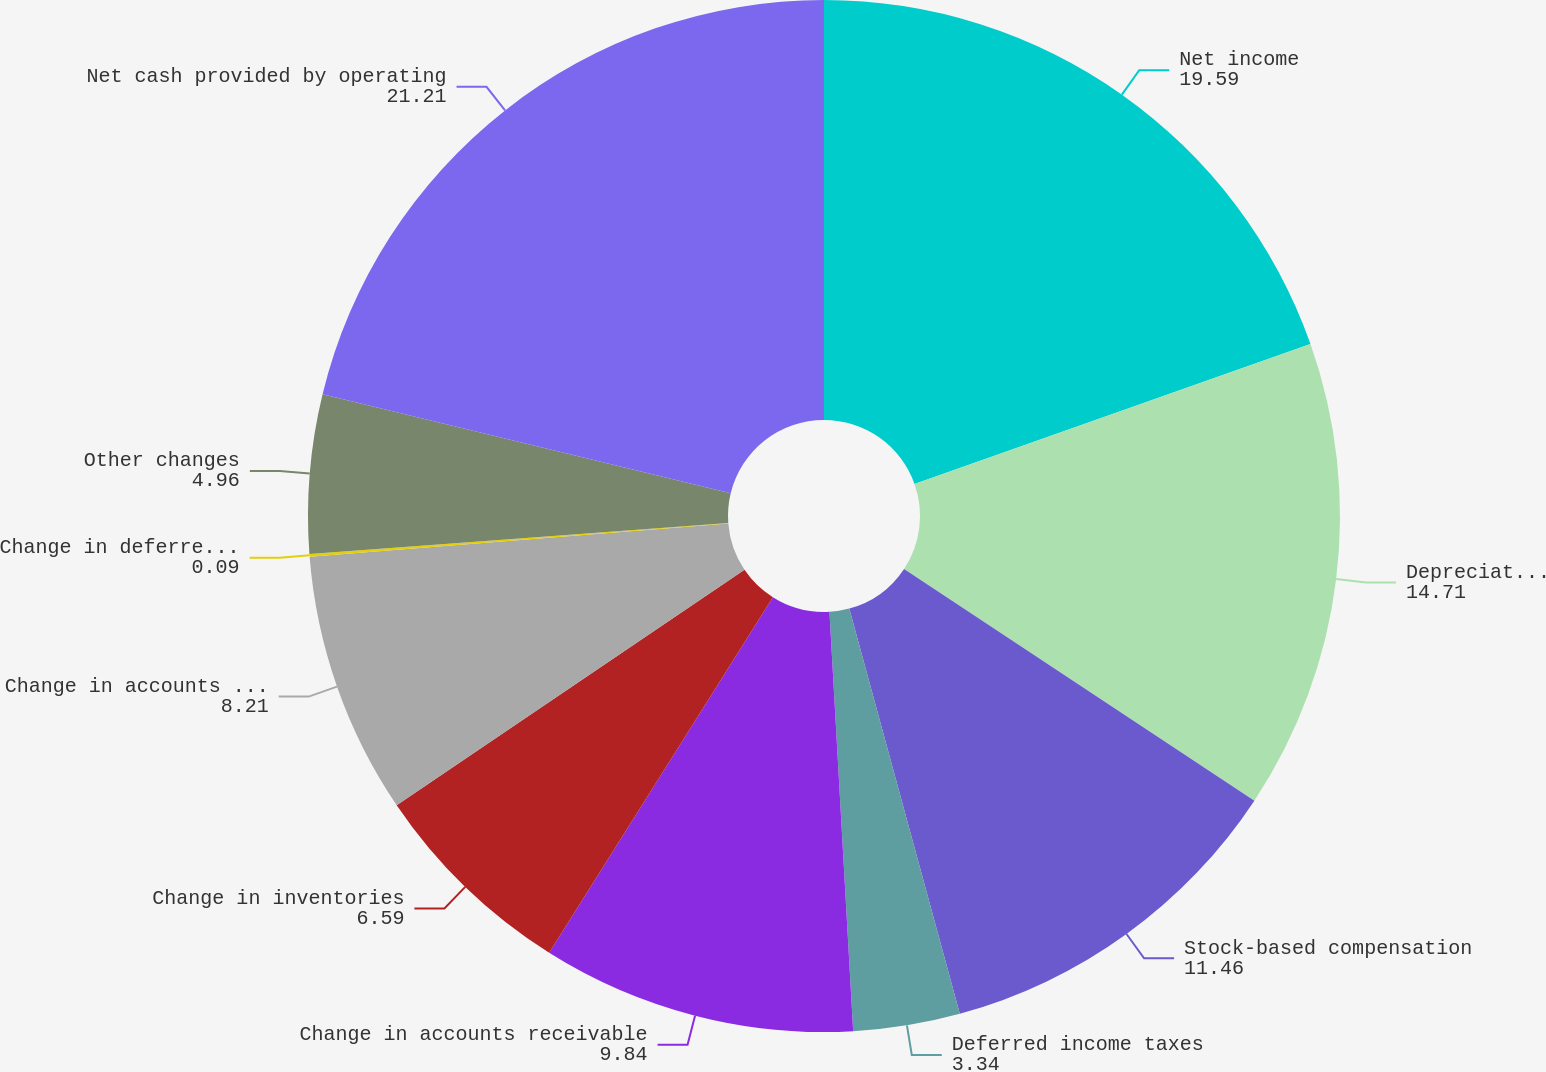Convert chart to OTSL. <chart><loc_0><loc_0><loc_500><loc_500><pie_chart><fcel>Net income<fcel>Depreciation and amortization<fcel>Stock-based compensation<fcel>Deferred income taxes<fcel>Change in accounts receivable<fcel>Change in inventories<fcel>Change in accounts payable and<fcel>Change in deferred revenue and<fcel>Other changes<fcel>Net cash provided by operating<nl><fcel>19.59%<fcel>14.71%<fcel>11.46%<fcel>3.34%<fcel>9.84%<fcel>6.59%<fcel>8.21%<fcel>0.09%<fcel>4.96%<fcel>21.21%<nl></chart> 